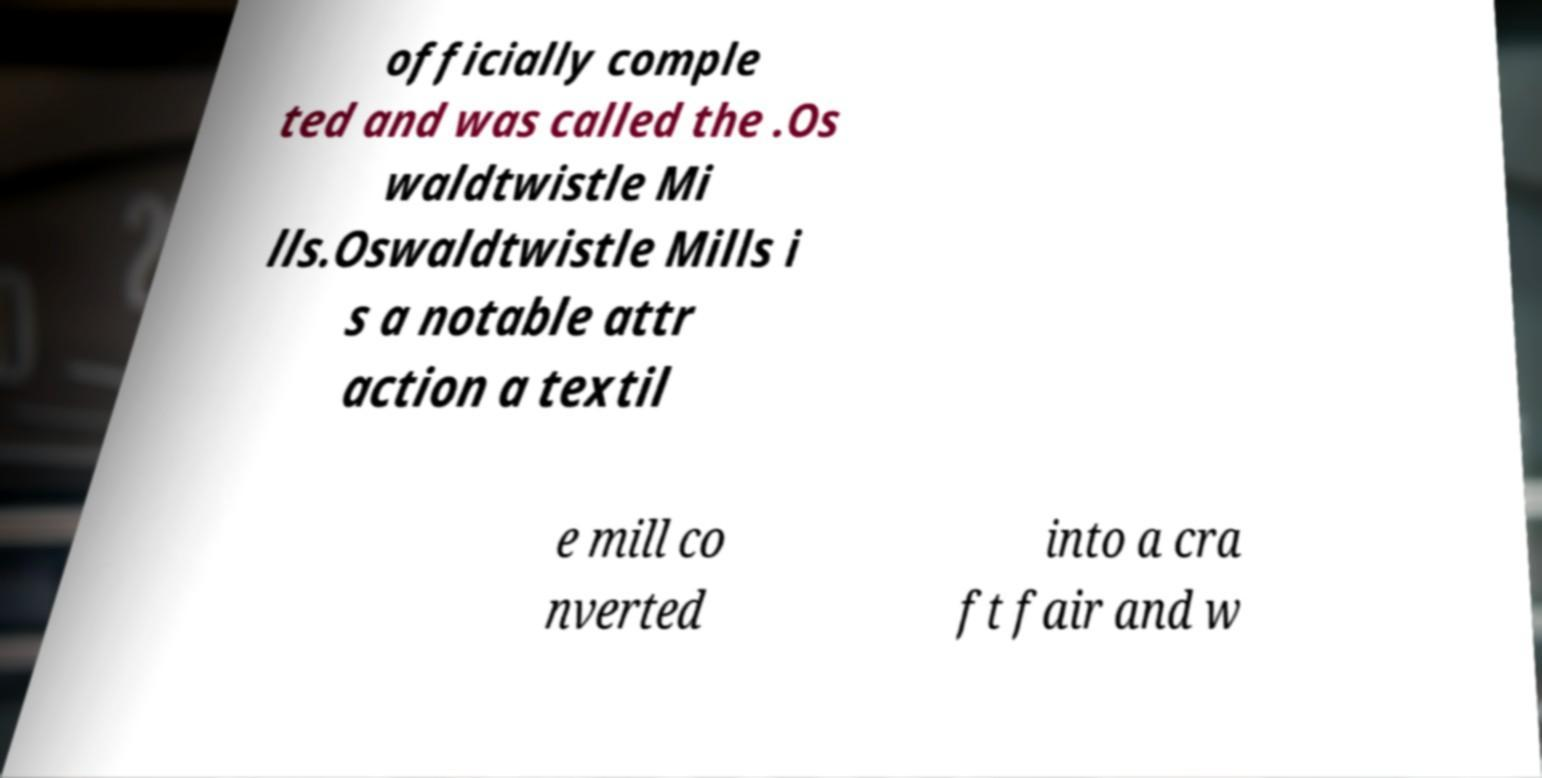Could you extract and type out the text from this image? officially comple ted and was called the .Os waldtwistle Mi lls.Oswaldtwistle Mills i s a notable attr action a textil e mill co nverted into a cra ft fair and w 